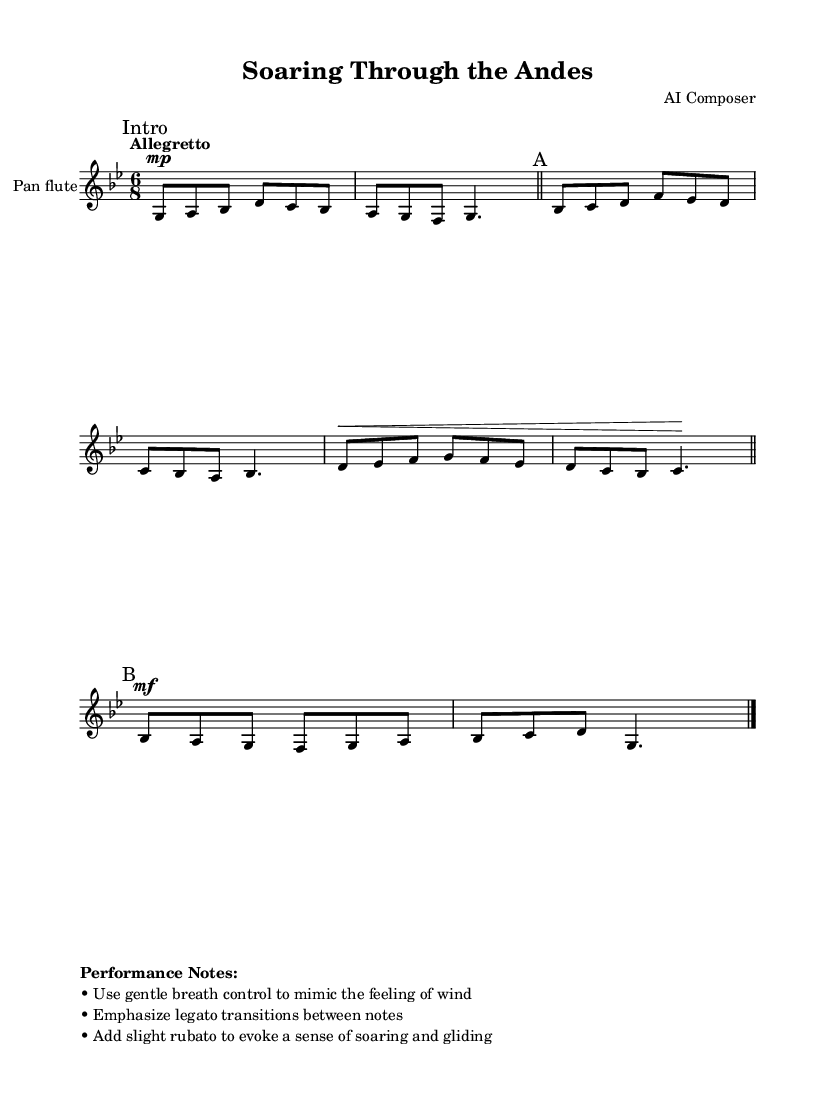What is the key signature of this music? The key signature is G minor, which features two flats: B and E. This can be determined by looking at the left side of the staff where the key signature is notated.
Answer: G minor What is the time signature of this piece? The time signature is 6/8, indicated at the beginning of the staff. This means there are six eighth notes in each measure.
Answer: 6/8 What is the tempo marking for this piece? The tempo marking is "Allegretto," which suggests a moderately fast pace, typically between 98 and 109 beats per minute. This is found at the start of the score, marking the intended speed of the performance.
Answer: Allegretto What dynamics are indicated for the "A" section? The "A" section marks indicate a dynamic level of mezzo-forte, which instructs the performer to play moderately loud. This is identified by the "mf" marking before the start of this section.
Answer: mezzo-forte How many measures are there in section A? There are four measures in section A, as indicated by the measure barlines created at the end of each group of notes within the section.
Answer: 4 measures What performance technique is suggested to mimic the feeling of wind? The piece suggests using gentle breath control to mimic the feeling of wind, elaborated in the performance notes provided at the bottom of the score.
Answer: Gentle breath control What is the function of the dynamic markings in this piece? The dynamic markings indicate how loudly or softly the musician should play. They help convey emotion throughout the piece, particularly the contrasts between sections, enhancing the feeling of soaring through the Andes.
Answer: Indicate dynamics 